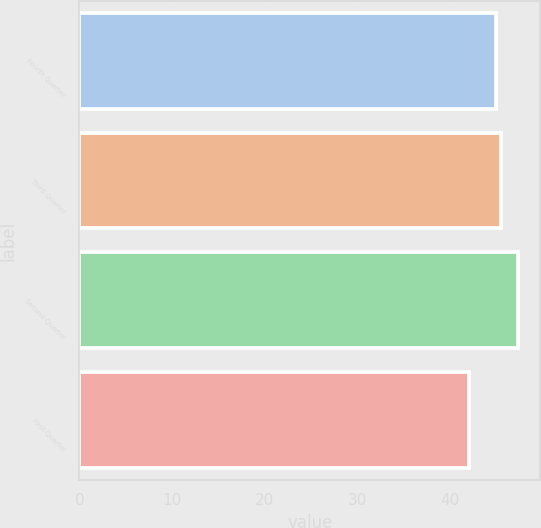Convert chart to OTSL. <chart><loc_0><loc_0><loc_500><loc_500><bar_chart><fcel>Fourth Quarter<fcel>Third Quarter<fcel>Second Quarter<fcel>First Quarter<nl><fcel>45.01<fcel>45.54<fcel>47.39<fcel>42.11<nl></chart> 